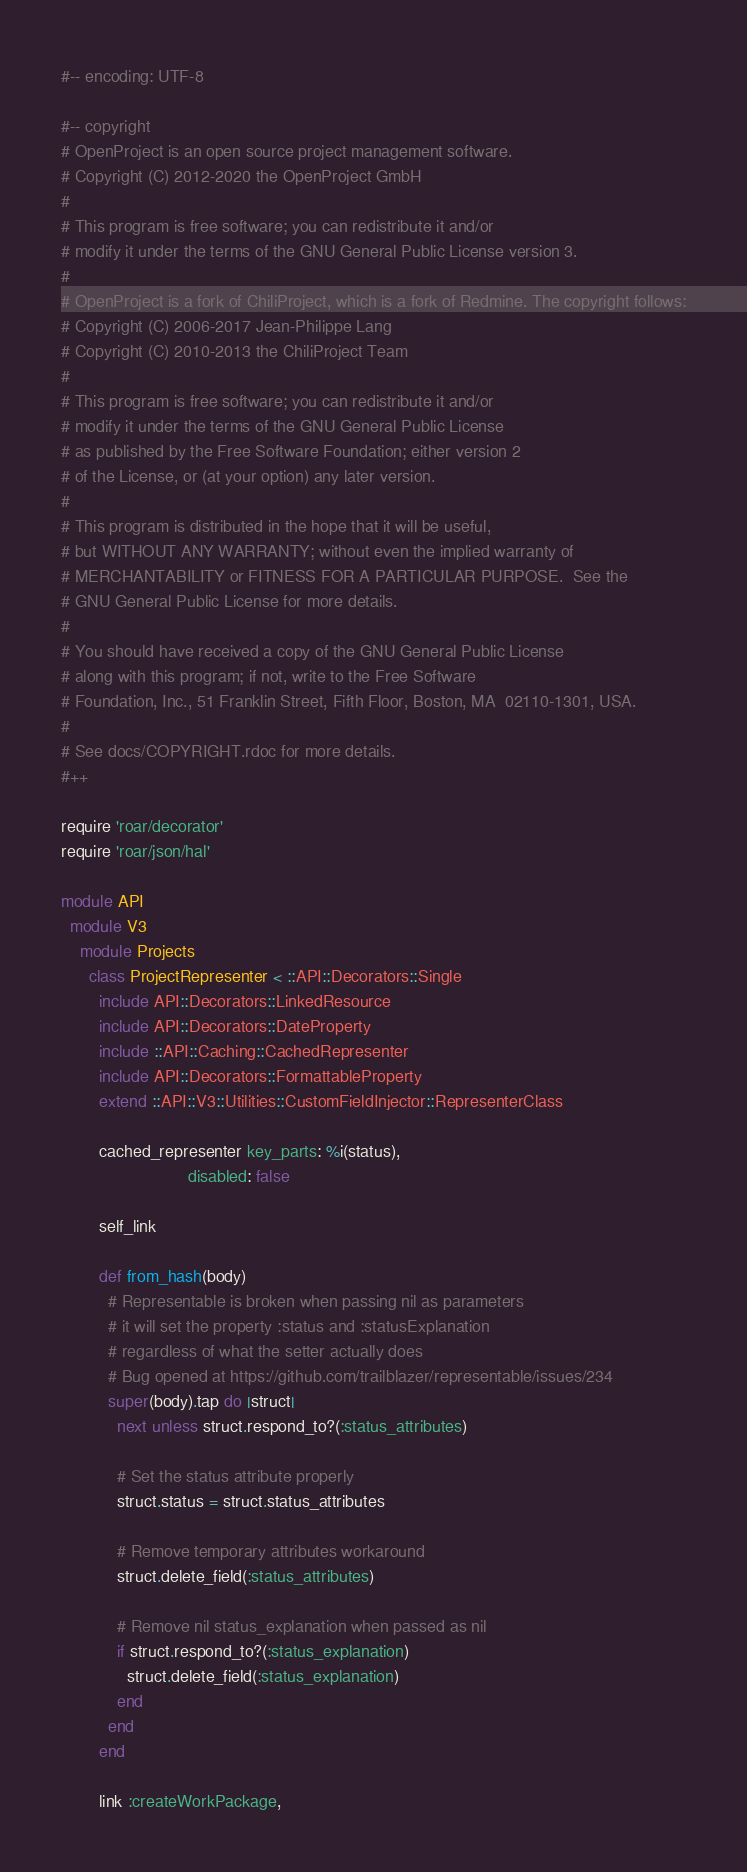<code> <loc_0><loc_0><loc_500><loc_500><_Ruby_>#-- encoding: UTF-8

#-- copyright
# OpenProject is an open source project management software.
# Copyright (C) 2012-2020 the OpenProject GmbH
#
# This program is free software; you can redistribute it and/or
# modify it under the terms of the GNU General Public License version 3.
#
# OpenProject is a fork of ChiliProject, which is a fork of Redmine. The copyright follows:
# Copyright (C) 2006-2017 Jean-Philippe Lang
# Copyright (C) 2010-2013 the ChiliProject Team
#
# This program is free software; you can redistribute it and/or
# modify it under the terms of the GNU General Public License
# as published by the Free Software Foundation; either version 2
# of the License, or (at your option) any later version.
#
# This program is distributed in the hope that it will be useful,
# but WITHOUT ANY WARRANTY; without even the implied warranty of
# MERCHANTABILITY or FITNESS FOR A PARTICULAR PURPOSE.  See the
# GNU General Public License for more details.
#
# You should have received a copy of the GNU General Public License
# along with this program; if not, write to the Free Software
# Foundation, Inc., 51 Franklin Street, Fifth Floor, Boston, MA  02110-1301, USA.
#
# See docs/COPYRIGHT.rdoc for more details.
#++

require 'roar/decorator'
require 'roar/json/hal'

module API
  module V3
    module Projects
      class ProjectRepresenter < ::API::Decorators::Single
        include API::Decorators::LinkedResource
        include API::Decorators::DateProperty
        include ::API::Caching::CachedRepresenter
        include API::Decorators::FormattableProperty
        extend ::API::V3::Utilities::CustomFieldInjector::RepresenterClass

        cached_representer key_parts: %i(status),
                           disabled: false

        self_link

        def from_hash(body)
          # Representable is broken when passing nil as parameters
          # it will set the property :status and :statusExplanation
          # regardless of what the setter actually does
          # Bug opened at https://github.com/trailblazer/representable/issues/234
          super(body).tap do |struct|
            next unless struct.respond_to?(:status_attributes)

            # Set the status attribute properly
            struct.status = struct.status_attributes

            # Remove temporary attributes workaround
            struct.delete_field(:status_attributes)

            # Remove nil status_explanation when passed as nil
            if struct.respond_to?(:status_explanation)
              struct.delete_field(:status_explanation)
            end
          end
        end

        link :createWorkPackage,</code> 